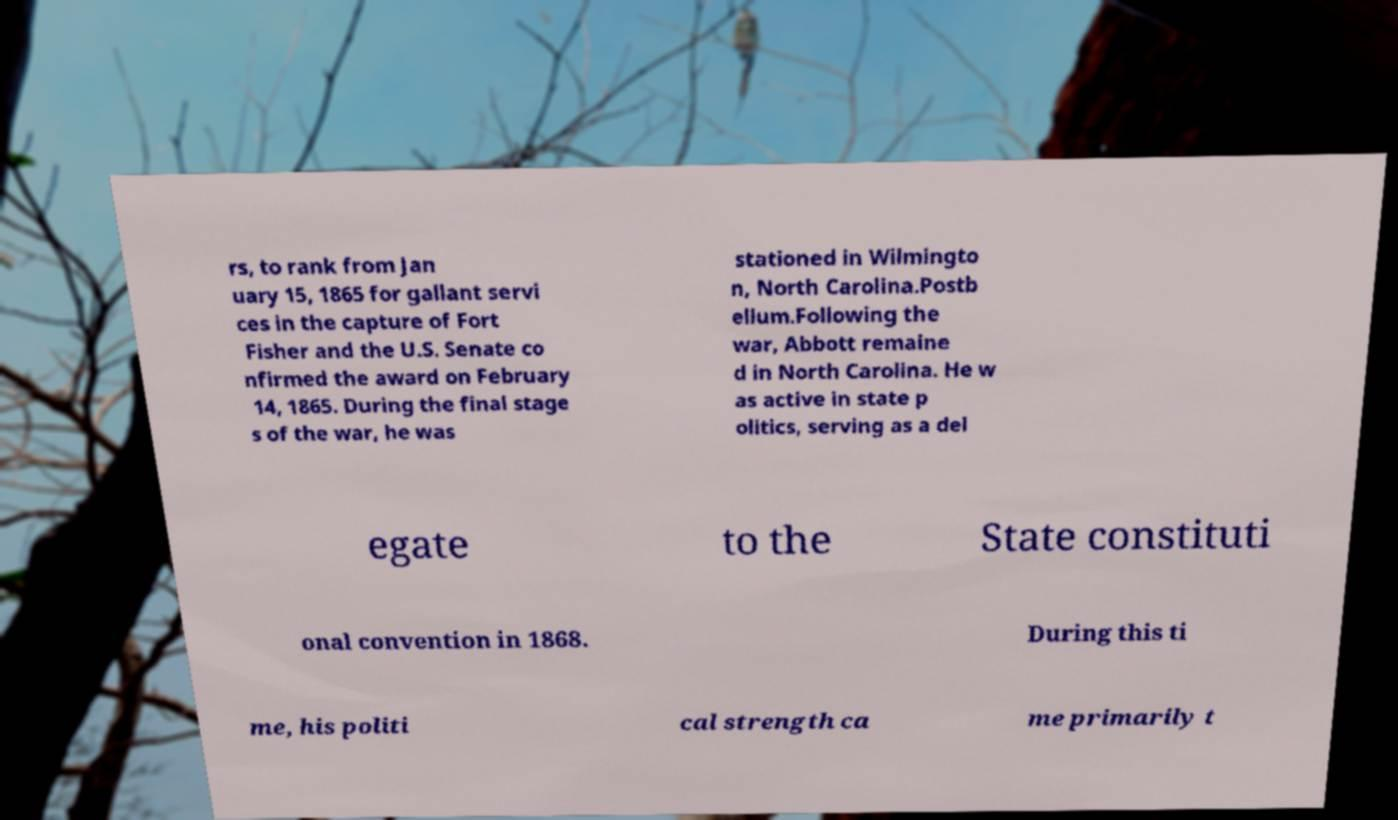There's text embedded in this image that I need extracted. Can you transcribe it verbatim? rs, to rank from Jan uary 15, 1865 for gallant servi ces in the capture of Fort Fisher and the U.S. Senate co nfirmed the award on February 14, 1865. During the final stage s of the war, he was stationed in Wilmingto n, North Carolina.Postb ellum.Following the war, Abbott remaine d in North Carolina. He w as active in state p olitics, serving as a del egate to the State constituti onal convention in 1868. During this ti me, his politi cal strength ca me primarily t 